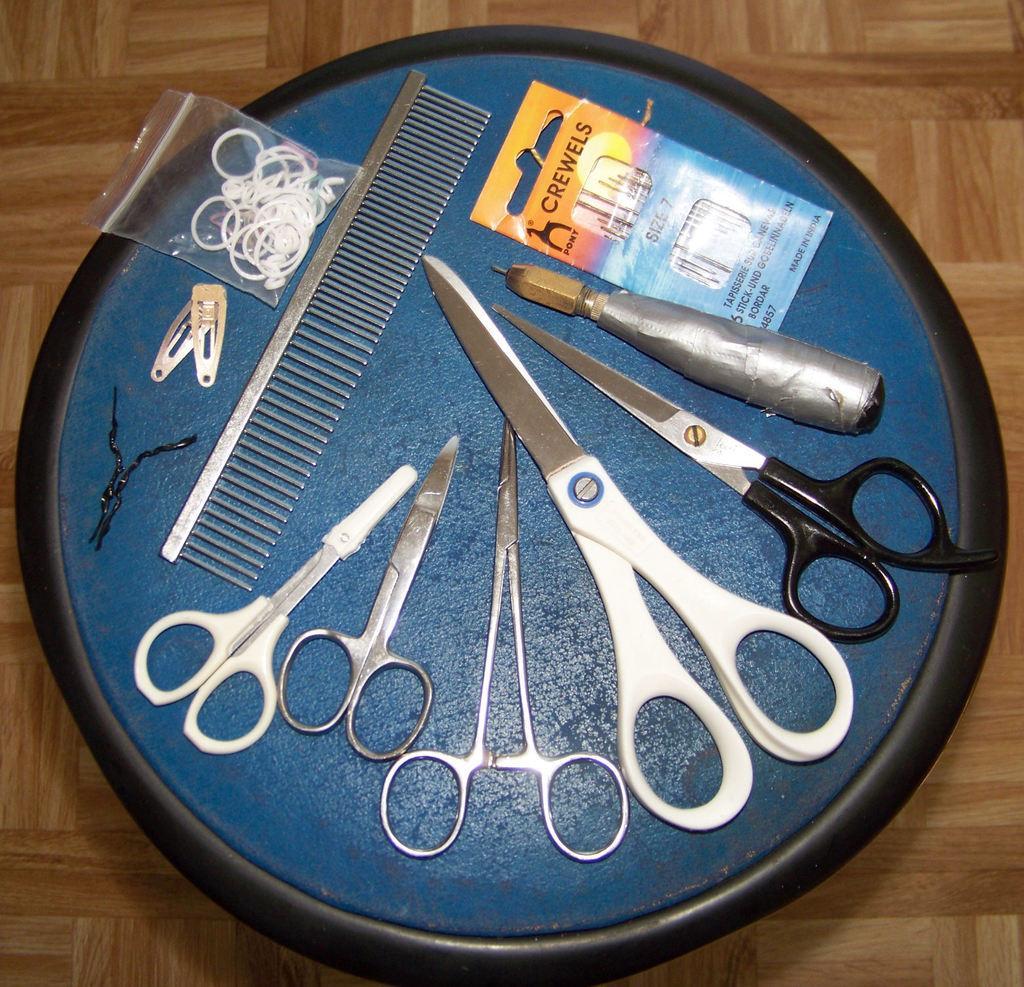In one or two sentences, can you explain what this image depicts? In this image there are scissors, pins and some tools placed on the tray. At the bottom we can see a wooden surface. 